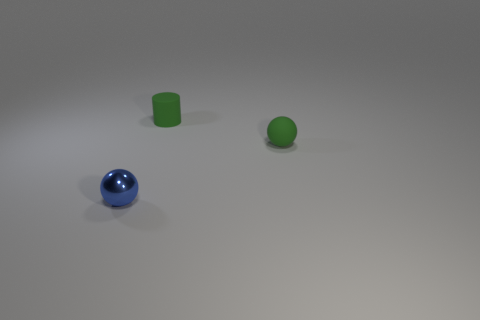Do the small green cylinder and the tiny green object in front of the tiny matte cylinder have the same material?
Make the answer very short. Yes. There is a green matte thing that is behind the tiny ball that is behind the blue ball; what is its shape?
Make the answer very short. Cylinder. There is a small shiny thing; is its color the same as the rubber object behind the tiny green sphere?
Your response must be concise. No. Is there anything else that has the same material as the cylinder?
Your response must be concise. Yes. The shiny thing is what shape?
Your answer should be compact. Sphere. How big is the ball behind the ball to the left of the tiny green matte cylinder?
Provide a succinct answer. Small. Are there the same number of green matte objects in front of the blue metal ball and tiny cylinders that are behind the cylinder?
Your answer should be very brief. Yes. The object that is on the left side of the small matte ball and behind the tiny blue metal thing is made of what material?
Your response must be concise. Rubber. There is a shiny ball; does it have the same size as the ball on the right side of the cylinder?
Ensure brevity in your answer.  Yes. What number of other objects are the same color as the tiny cylinder?
Offer a very short reply. 1. 